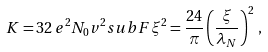Convert formula to latex. <formula><loc_0><loc_0><loc_500><loc_500>K = 3 2 \, e ^ { 2 } N _ { 0 } v ^ { 2 } _ { \ } s u b F \xi ^ { 2 } = \frac { 2 4 } { \pi } \left ( \frac { \xi } { \lambda _ { N } } \right ) ^ { 2 } \, ,</formula> 